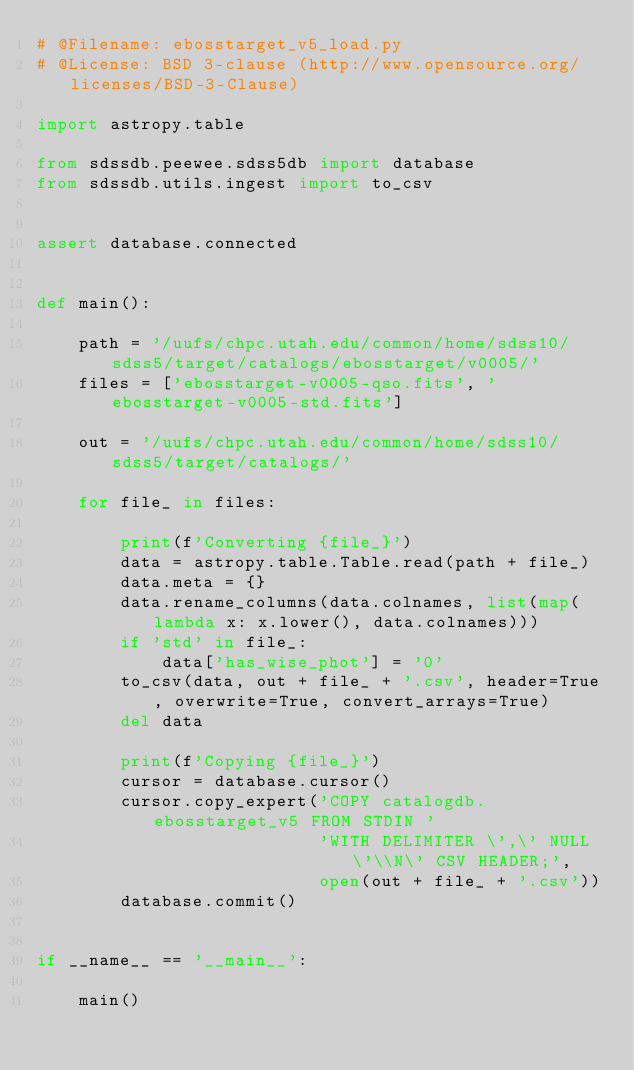Convert code to text. <code><loc_0><loc_0><loc_500><loc_500><_Python_># @Filename: ebosstarget_v5_load.py
# @License: BSD 3-clause (http://www.opensource.org/licenses/BSD-3-Clause)

import astropy.table

from sdssdb.peewee.sdss5db import database
from sdssdb.utils.ingest import to_csv


assert database.connected


def main():

    path = '/uufs/chpc.utah.edu/common/home/sdss10/sdss5/target/catalogs/ebosstarget/v0005/'
    files = ['ebosstarget-v0005-qso.fits', 'ebosstarget-v0005-std.fits']

    out = '/uufs/chpc.utah.edu/common/home/sdss10/sdss5/target/catalogs/'

    for file_ in files:

        print(f'Converting {file_}')
        data = astropy.table.Table.read(path + file_)
        data.meta = {}
        data.rename_columns(data.colnames, list(map(lambda x: x.lower(), data.colnames)))
        if 'std' in file_:
            data['has_wise_phot'] = '0'
        to_csv(data, out + file_ + '.csv', header=True, overwrite=True, convert_arrays=True)
        del data

        print(f'Copying {file_}')
        cursor = database.cursor()
        cursor.copy_expert('COPY catalogdb.ebosstarget_v5 FROM STDIN '
                           'WITH DELIMITER \',\' NULL \'\\N\' CSV HEADER;',
                           open(out + file_ + '.csv'))
        database.commit()


if __name__ == '__main__':

    main()
</code> 